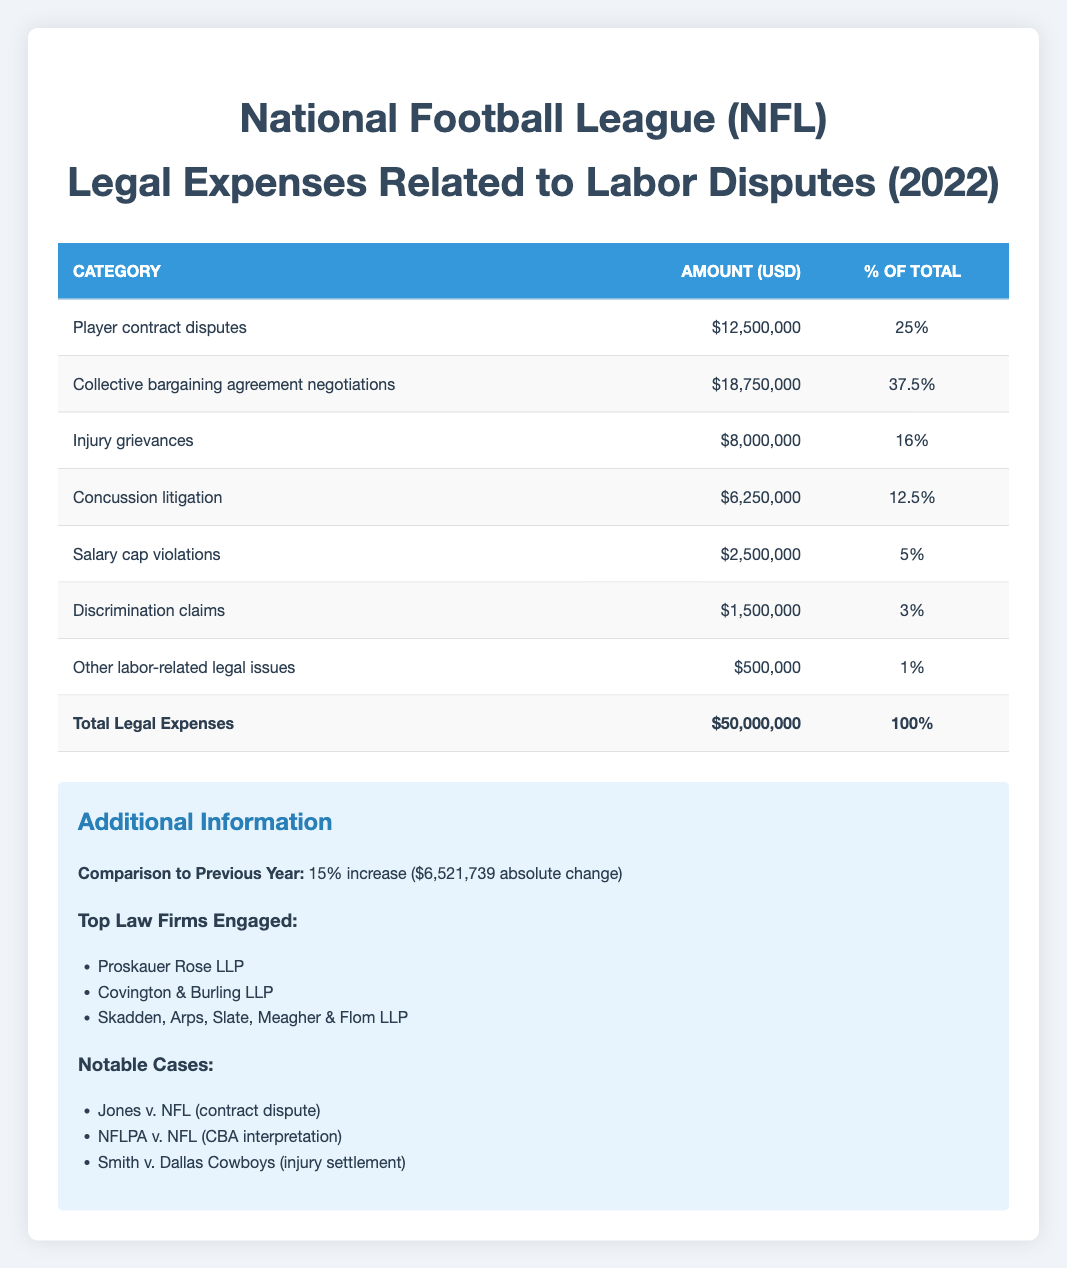What is the total amount spent on legal expenses in 2022? The table indicates that the total legal expenses for the NFL in 2022 are listed as $50,000,000.
Answer: $50,000,000 What percentage of the total legal expenses is attributed to collective bargaining agreement negotiations? From the table, we see that collective bargaining agreement negotiations account for 37.5% of the total legal expenses.
Answer: 37.5% How much has the legal expenses increased compared to the previous year? The table states that there was a 15% increase in legal expenses compared to the previous year, with an absolute change of $6,521,739.
Answer: $6,521,739 Is the amount spent on discrimination claims higher than that for salary cap violations? By comparing the amounts in the table, discrimination claims amount to $1,500,000 while salary cap violations amount to $2,500,000. Since $1,500,000 is less than $2,500,000, the answer is no.
Answer: No What is the total amount spent on player contract disputes and concussion litigation combined? To find this, we add the amounts for player contract disputes ($12,500,000) and concussion litigation ($6,250,000). Adding these gives us $12,500,000 + $6,250,000 = $18,750,000.
Answer: $18,750,000 Which category has the lowest legal expenses? Referring to the amounts in the table, the category "Other labor-related legal issues" has the lowest amount at $500,000.
Answer: Other labor-related legal issues What is the average percentage of total legal expenses across all categories listed? To calculate the average percentage, we take the total percentage of all categories, which is 100%, and divide it by the number of categories (7). Thus, the average is 100% / 7 = approximately 14.29%.
Answer: Approximately 14.29% Which law firm engaged by the NFL is known for their experience in labor-related disputes? Proskauer Rose LLP is listed among the top law firms engaged, which is known for handling labor-related cases.
Answer: Proskauer Rose LLP Did the top three law firms engaged have any connection to the notable cases listed? The table highlights top law firms engaged, but does not specify their connection to notable cases. Therefore, based on the provided information, we cannot confirm any specific connections.
Answer: Insufficient information to determine 